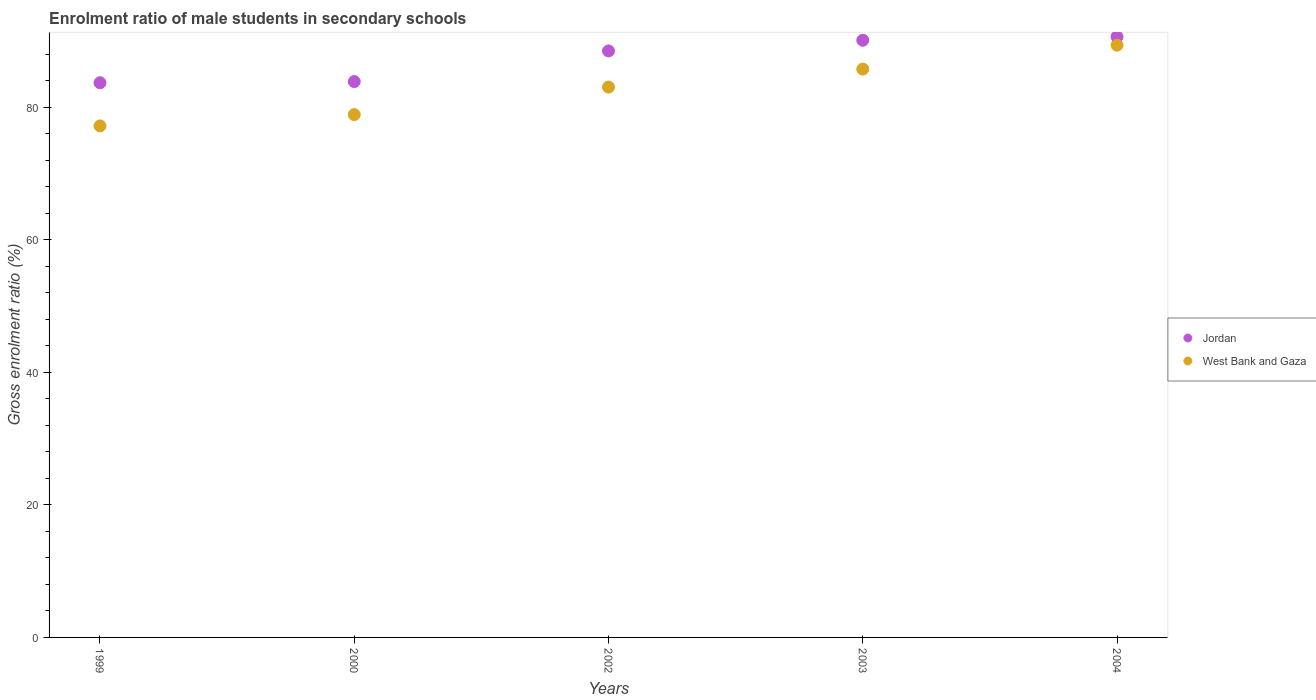How many different coloured dotlines are there?
Provide a short and direct response. 2. What is the enrolment ratio of male students in secondary schools in Jordan in 1999?
Give a very brief answer. 83.71. Across all years, what is the maximum enrolment ratio of male students in secondary schools in Jordan?
Make the answer very short. 90.66. Across all years, what is the minimum enrolment ratio of male students in secondary schools in Jordan?
Your answer should be very brief. 83.71. In which year was the enrolment ratio of male students in secondary schools in West Bank and Gaza maximum?
Your answer should be very brief. 2004. In which year was the enrolment ratio of male students in secondary schools in West Bank and Gaza minimum?
Keep it short and to the point. 1999. What is the total enrolment ratio of male students in secondary schools in Jordan in the graph?
Give a very brief answer. 436.88. What is the difference between the enrolment ratio of male students in secondary schools in Jordan in 2000 and that in 2002?
Offer a terse response. -4.62. What is the difference between the enrolment ratio of male students in secondary schools in West Bank and Gaza in 2002 and the enrolment ratio of male students in secondary schools in Jordan in 2000?
Provide a short and direct response. -0.83. What is the average enrolment ratio of male students in secondary schools in Jordan per year?
Your answer should be very brief. 87.38. In the year 2003, what is the difference between the enrolment ratio of male students in secondary schools in West Bank and Gaza and enrolment ratio of male students in secondary schools in Jordan?
Provide a short and direct response. -4.35. What is the ratio of the enrolment ratio of male students in secondary schools in West Bank and Gaza in 1999 to that in 2003?
Ensure brevity in your answer.  0.9. What is the difference between the highest and the second highest enrolment ratio of male students in secondary schools in Jordan?
Keep it short and to the point. 0.53. What is the difference between the highest and the lowest enrolment ratio of male students in secondary schools in West Bank and Gaza?
Provide a succinct answer. 12.18. Does the enrolment ratio of male students in secondary schools in Jordan monotonically increase over the years?
Offer a terse response. Yes. Is the enrolment ratio of male students in secondary schools in West Bank and Gaza strictly greater than the enrolment ratio of male students in secondary schools in Jordan over the years?
Provide a succinct answer. No. How many years are there in the graph?
Make the answer very short. 5. Are the values on the major ticks of Y-axis written in scientific E-notation?
Make the answer very short. No. Does the graph contain grids?
Offer a very short reply. No. How are the legend labels stacked?
Offer a very short reply. Vertical. What is the title of the graph?
Make the answer very short. Enrolment ratio of male students in secondary schools. What is the Gross enrolment ratio (%) in Jordan in 1999?
Offer a very short reply. 83.71. What is the Gross enrolment ratio (%) of West Bank and Gaza in 1999?
Make the answer very short. 77.2. What is the Gross enrolment ratio (%) in Jordan in 2000?
Give a very brief answer. 83.89. What is the Gross enrolment ratio (%) of West Bank and Gaza in 2000?
Your response must be concise. 78.91. What is the Gross enrolment ratio (%) in Jordan in 2002?
Your answer should be compact. 88.51. What is the Gross enrolment ratio (%) of West Bank and Gaza in 2002?
Your answer should be compact. 83.05. What is the Gross enrolment ratio (%) in Jordan in 2003?
Provide a succinct answer. 90.12. What is the Gross enrolment ratio (%) in West Bank and Gaza in 2003?
Your answer should be very brief. 85.77. What is the Gross enrolment ratio (%) of Jordan in 2004?
Your answer should be compact. 90.66. What is the Gross enrolment ratio (%) in West Bank and Gaza in 2004?
Provide a succinct answer. 89.38. Across all years, what is the maximum Gross enrolment ratio (%) of Jordan?
Make the answer very short. 90.66. Across all years, what is the maximum Gross enrolment ratio (%) in West Bank and Gaza?
Keep it short and to the point. 89.38. Across all years, what is the minimum Gross enrolment ratio (%) of Jordan?
Ensure brevity in your answer.  83.71. Across all years, what is the minimum Gross enrolment ratio (%) in West Bank and Gaza?
Provide a short and direct response. 77.2. What is the total Gross enrolment ratio (%) in Jordan in the graph?
Give a very brief answer. 436.88. What is the total Gross enrolment ratio (%) of West Bank and Gaza in the graph?
Your answer should be very brief. 414.3. What is the difference between the Gross enrolment ratio (%) in Jordan in 1999 and that in 2000?
Provide a succinct answer. -0.18. What is the difference between the Gross enrolment ratio (%) of West Bank and Gaza in 1999 and that in 2000?
Offer a terse response. -1.71. What is the difference between the Gross enrolment ratio (%) in Jordan in 1999 and that in 2002?
Give a very brief answer. -4.8. What is the difference between the Gross enrolment ratio (%) of West Bank and Gaza in 1999 and that in 2002?
Give a very brief answer. -5.86. What is the difference between the Gross enrolment ratio (%) of Jordan in 1999 and that in 2003?
Your response must be concise. -6.41. What is the difference between the Gross enrolment ratio (%) in West Bank and Gaza in 1999 and that in 2003?
Give a very brief answer. -8.58. What is the difference between the Gross enrolment ratio (%) in Jordan in 1999 and that in 2004?
Your response must be concise. -6.95. What is the difference between the Gross enrolment ratio (%) of West Bank and Gaza in 1999 and that in 2004?
Keep it short and to the point. -12.18. What is the difference between the Gross enrolment ratio (%) of Jordan in 2000 and that in 2002?
Your answer should be very brief. -4.62. What is the difference between the Gross enrolment ratio (%) of West Bank and Gaza in 2000 and that in 2002?
Provide a succinct answer. -4.15. What is the difference between the Gross enrolment ratio (%) of Jordan in 2000 and that in 2003?
Provide a short and direct response. -6.24. What is the difference between the Gross enrolment ratio (%) of West Bank and Gaza in 2000 and that in 2003?
Provide a succinct answer. -6.87. What is the difference between the Gross enrolment ratio (%) of Jordan in 2000 and that in 2004?
Offer a terse response. -6.77. What is the difference between the Gross enrolment ratio (%) in West Bank and Gaza in 2000 and that in 2004?
Provide a succinct answer. -10.47. What is the difference between the Gross enrolment ratio (%) of Jordan in 2002 and that in 2003?
Offer a terse response. -1.61. What is the difference between the Gross enrolment ratio (%) in West Bank and Gaza in 2002 and that in 2003?
Give a very brief answer. -2.72. What is the difference between the Gross enrolment ratio (%) of Jordan in 2002 and that in 2004?
Give a very brief answer. -2.15. What is the difference between the Gross enrolment ratio (%) of West Bank and Gaza in 2002 and that in 2004?
Make the answer very short. -6.32. What is the difference between the Gross enrolment ratio (%) in Jordan in 2003 and that in 2004?
Ensure brevity in your answer.  -0.53. What is the difference between the Gross enrolment ratio (%) of West Bank and Gaza in 2003 and that in 2004?
Offer a very short reply. -3.6. What is the difference between the Gross enrolment ratio (%) in Jordan in 1999 and the Gross enrolment ratio (%) in West Bank and Gaza in 2000?
Your response must be concise. 4.8. What is the difference between the Gross enrolment ratio (%) in Jordan in 1999 and the Gross enrolment ratio (%) in West Bank and Gaza in 2002?
Your answer should be compact. 0.66. What is the difference between the Gross enrolment ratio (%) of Jordan in 1999 and the Gross enrolment ratio (%) of West Bank and Gaza in 2003?
Ensure brevity in your answer.  -2.06. What is the difference between the Gross enrolment ratio (%) in Jordan in 1999 and the Gross enrolment ratio (%) in West Bank and Gaza in 2004?
Provide a short and direct response. -5.67. What is the difference between the Gross enrolment ratio (%) of Jordan in 2000 and the Gross enrolment ratio (%) of West Bank and Gaza in 2002?
Provide a short and direct response. 0.83. What is the difference between the Gross enrolment ratio (%) in Jordan in 2000 and the Gross enrolment ratio (%) in West Bank and Gaza in 2003?
Your response must be concise. -1.89. What is the difference between the Gross enrolment ratio (%) of Jordan in 2000 and the Gross enrolment ratio (%) of West Bank and Gaza in 2004?
Provide a succinct answer. -5.49. What is the difference between the Gross enrolment ratio (%) of Jordan in 2002 and the Gross enrolment ratio (%) of West Bank and Gaza in 2003?
Offer a very short reply. 2.74. What is the difference between the Gross enrolment ratio (%) of Jordan in 2002 and the Gross enrolment ratio (%) of West Bank and Gaza in 2004?
Your answer should be compact. -0.87. What is the difference between the Gross enrolment ratio (%) of Jordan in 2003 and the Gross enrolment ratio (%) of West Bank and Gaza in 2004?
Make the answer very short. 0.75. What is the average Gross enrolment ratio (%) of Jordan per year?
Make the answer very short. 87.38. What is the average Gross enrolment ratio (%) of West Bank and Gaza per year?
Offer a terse response. 82.86. In the year 1999, what is the difference between the Gross enrolment ratio (%) in Jordan and Gross enrolment ratio (%) in West Bank and Gaza?
Offer a terse response. 6.51. In the year 2000, what is the difference between the Gross enrolment ratio (%) in Jordan and Gross enrolment ratio (%) in West Bank and Gaza?
Offer a very short reply. 4.98. In the year 2002, what is the difference between the Gross enrolment ratio (%) in Jordan and Gross enrolment ratio (%) in West Bank and Gaza?
Give a very brief answer. 5.46. In the year 2003, what is the difference between the Gross enrolment ratio (%) of Jordan and Gross enrolment ratio (%) of West Bank and Gaza?
Keep it short and to the point. 4.35. In the year 2004, what is the difference between the Gross enrolment ratio (%) in Jordan and Gross enrolment ratio (%) in West Bank and Gaza?
Provide a short and direct response. 1.28. What is the ratio of the Gross enrolment ratio (%) in Jordan in 1999 to that in 2000?
Your answer should be very brief. 1. What is the ratio of the Gross enrolment ratio (%) in West Bank and Gaza in 1999 to that in 2000?
Give a very brief answer. 0.98. What is the ratio of the Gross enrolment ratio (%) of Jordan in 1999 to that in 2002?
Provide a short and direct response. 0.95. What is the ratio of the Gross enrolment ratio (%) in West Bank and Gaza in 1999 to that in 2002?
Make the answer very short. 0.93. What is the ratio of the Gross enrolment ratio (%) in Jordan in 1999 to that in 2003?
Your answer should be very brief. 0.93. What is the ratio of the Gross enrolment ratio (%) of Jordan in 1999 to that in 2004?
Provide a succinct answer. 0.92. What is the ratio of the Gross enrolment ratio (%) in West Bank and Gaza in 1999 to that in 2004?
Your answer should be compact. 0.86. What is the ratio of the Gross enrolment ratio (%) in Jordan in 2000 to that in 2002?
Give a very brief answer. 0.95. What is the ratio of the Gross enrolment ratio (%) in West Bank and Gaza in 2000 to that in 2002?
Make the answer very short. 0.95. What is the ratio of the Gross enrolment ratio (%) in Jordan in 2000 to that in 2003?
Make the answer very short. 0.93. What is the ratio of the Gross enrolment ratio (%) in West Bank and Gaza in 2000 to that in 2003?
Offer a very short reply. 0.92. What is the ratio of the Gross enrolment ratio (%) of Jordan in 2000 to that in 2004?
Provide a short and direct response. 0.93. What is the ratio of the Gross enrolment ratio (%) in West Bank and Gaza in 2000 to that in 2004?
Offer a very short reply. 0.88. What is the ratio of the Gross enrolment ratio (%) in Jordan in 2002 to that in 2003?
Your response must be concise. 0.98. What is the ratio of the Gross enrolment ratio (%) in West Bank and Gaza in 2002 to that in 2003?
Ensure brevity in your answer.  0.97. What is the ratio of the Gross enrolment ratio (%) in Jordan in 2002 to that in 2004?
Your response must be concise. 0.98. What is the ratio of the Gross enrolment ratio (%) of West Bank and Gaza in 2002 to that in 2004?
Give a very brief answer. 0.93. What is the ratio of the Gross enrolment ratio (%) in West Bank and Gaza in 2003 to that in 2004?
Your answer should be very brief. 0.96. What is the difference between the highest and the second highest Gross enrolment ratio (%) in Jordan?
Make the answer very short. 0.53. What is the difference between the highest and the second highest Gross enrolment ratio (%) in West Bank and Gaza?
Keep it short and to the point. 3.6. What is the difference between the highest and the lowest Gross enrolment ratio (%) in Jordan?
Provide a short and direct response. 6.95. What is the difference between the highest and the lowest Gross enrolment ratio (%) of West Bank and Gaza?
Ensure brevity in your answer.  12.18. 